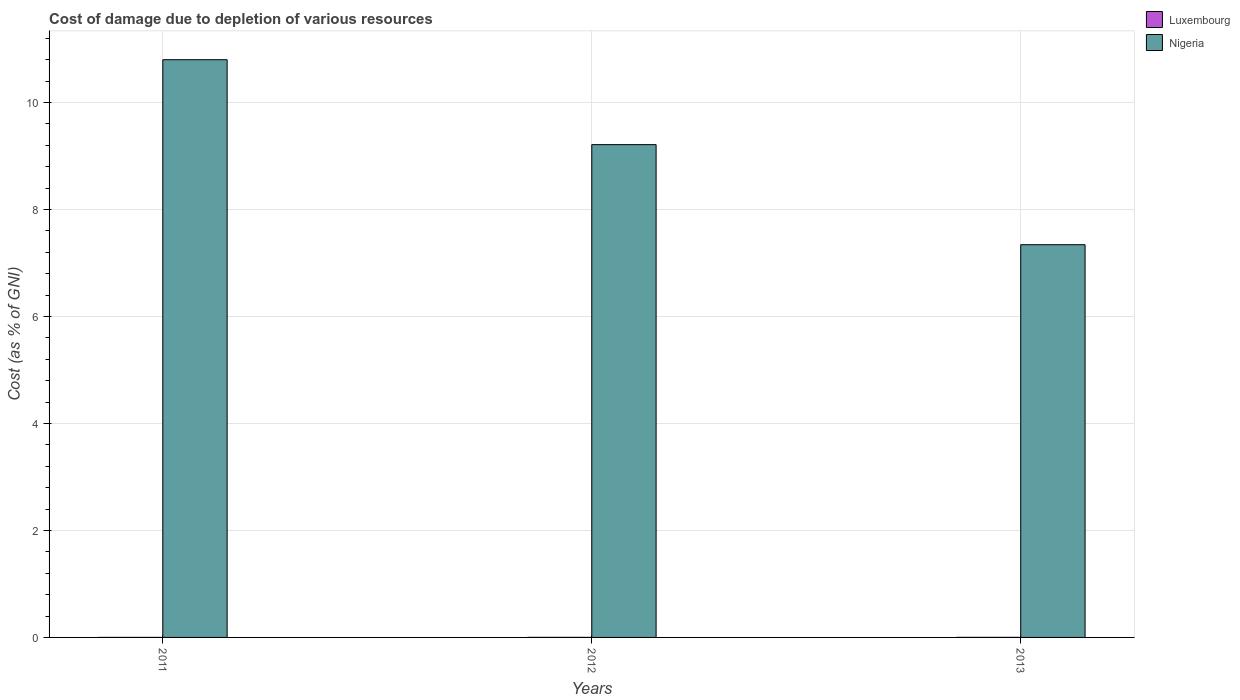How many different coloured bars are there?
Your response must be concise. 2. Are the number of bars per tick equal to the number of legend labels?
Make the answer very short. Yes. Are the number of bars on each tick of the X-axis equal?
Your response must be concise. Yes. How many bars are there on the 1st tick from the right?
Your response must be concise. 2. What is the cost of damage caused due to the depletion of various resources in Nigeria in 2012?
Give a very brief answer. 9.21. Across all years, what is the maximum cost of damage caused due to the depletion of various resources in Luxembourg?
Offer a terse response. 0. Across all years, what is the minimum cost of damage caused due to the depletion of various resources in Nigeria?
Provide a succinct answer. 7.34. In which year was the cost of damage caused due to the depletion of various resources in Nigeria minimum?
Offer a very short reply. 2013. What is the total cost of damage caused due to the depletion of various resources in Luxembourg in the graph?
Give a very brief answer. 0. What is the difference between the cost of damage caused due to the depletion of various resources in Nigeria in 2011 and that in 2012?
Make the answer very short. 1.59. What is the difference between the cost of damage caused due to the depletion of various resources in Nigeria in 2012 and the cost of damage caused due to the depletion of various resources in Luxembourg in 2013?
Offer a terse response. 9.21. What is the average cost of damage caused due to the depletion of various resources in Luxembourg per year?
Offer a very short reply. 0. In the year 2013, what is the difference between the cost of damage caused due to the depletion of various resources in Nigeria and cost of damage caused due to the depletion of various resources in Luxembourg?
Offer a terse response. 7.34. What is the ratio of the cost of damage caused due to the depletion of various resources in Nigeria in 2011 to that in 2013?
Give a very brief answer. 1.47. Is the cost of damage caused due to the depletion of various resources in Luxembourg in 2012 less than that in 2013?
Give a very brief answer. No. What is the difference between the highest and the second highest cost of damage caused due to the depletion of various resources in Nigeria?
Provide a short and direct response. 1.59. What is the difference between the highest and the lowest cost of damage caused due to the depletion of various resources in Nigeria?
Keep it short and to the point. 3.46. Is the sum of the cost of damage caused due to the depletion of various resources in Nigeria in 2011 and 2012 greater than the maximum cost of damage caused due to the depletion of various resources in Luxembourg across all years?
Ensure brevity in your answer.  Yes. What does the 1st bar from the left in 2011 represents?
Provide a succinct answer. Luxembourg. What does the 2nd bar from the right in 2013 represents?
Your answer should be compact. Luxembourg. How many bars are there?
Give a very brief answer. 6. Does the graph contain any zero values?
Make the answer very short. No. Does the graph contain grids?
Your response must be concise. Yes. How are the legend labels stacked?
Your response must be concise. Vertical. What is the title of the graph?
Keep it short and to the point. Cost of damage due to depletion of various resources. What is the label or title of the X-axis?
Your answer should be very brief. Years. What is the label or title of the Y-axis?
Ensure brevity in your answer.  Cost (as % of GNI). What is the Cost (as % of GNI) of Luxembourg in 2011?
Your answer should be compact. 0. What is the Cost (as % of GNI) of Nigeria in 2011?
Ensure brevity in your answer.  10.8. What is the Cost (as % of GNI) of Luxembourg in 2012?
Offer a terse response. 0. What is the Cost (as % of GNI) in Nigeria in 2012?
Offer a very short reply. 9.21. What is the Cost (as % of GNI) of Luxembourg in 2013?
Keep it short and to the point. 0. What is the Cost (as % of GNI) of Nigeria in 2013?
Ensure brevity in your answer.  7.34. Across all years, what is the maximum Cost (as % of GNI) in Luxembourg?
Offer a terse response. 0. Across all years, what is the maximum Cost (as % of GNI) of Nigeria?
Keep it short and to the point. 10.8. Across all years, what is the minimum Cost (as % of GNI) of Luxembourg?
Your answer should be very brief. 0. Across all years, what is the minimum Cost (as % of GNI) in Nigeria?
Give a very brief answer. 7.34. What is the total Cost (as % of GNI) in Luxembourg in the graph?
Keep it short and to the point. 0. What is the total Cost (as % of GNI) of Nigeria in the graph?
Offer a very short reply. 27.35. What is the difference between the Cost (as % of GNI) in Luxembourg in 2011 and that in 2012?
Your answer should be very brief. -0. What is the difference between the Cost (as % of GNI) in Nigeria in 2011 and that in 2012?
Make the answer very short. 1.59. What is the difference between the Cost (as % of GNI) in Luxembourg in 2011 and that in 2013?
Provide a succinct answer. -0. What is the difference between the Cost (as % of GNI) of Nigeria in 2011 and that in 2013?
Ensure brevity in your answer.  3.46. What is the difference between the Cost (as % of GNI) in Nigeria in 2012 and that in 2013?
Give a very brief answer. 1.87. What is the difference between the Cost (as % of GNI) in Luxembourg in 2011 and the Cost (as % of GNI) in Nigeria in 2012?
Your answer should be very brief. -9.21. What is the difference between the Cost (as % of GNI) in Luxembourg in 2011 and the Cost (as % of GNI) in Nigeria in 2013?
Ensure brevity in your answer.  -7.34. What is the difference between the Cost (as % of GNI) of Luxembourg in 2012 and the Cost (as % of GNI) of Nigeria in 2013?
Provide a succinct answer. -7.34. What is the average Cost (as % of GNI) in Luxembourg per year?
Provide a short and direct response. 0. What is the average Cost (as % of GNI) of Nigeria per year?
Give a very brief answer. 9.12. In the year 2011, what is the difference between the Cost (as % of GNI) in Luxembourg and Cost (as % of GNI) in Nigeria?
Provide a succinct answer. -10.8. In the year 2012, what is the difference between the Cost (as % of GNI) of Luxembourg and Cost (as % of GNI) of Nigeria?
Your answer should be compact. -9.21. In the year 2013, what is the difference between the Cost (as % of GNI) in Luxembourg and Cost (as % of GNI) in Nigeria?
Offer a terse response. -7.34. What is the ratio of the Cost (as % of GNI) in Luxembourg in 2011 to that in 2012?
Provide a short and direct response. 0.29. What is the ratio of the Cost (as % of GNI) of Nigeria in 2011 to that in 2012?
Ensure brevity in your answer.  1.17. What is the ratio of the Cost (as % of GNI) in Luxembourg in 2011 to that in 2013?
Provide a succinct answer. 0.3. What is the ratio of the Cost (as % of GNI) of Nigeria in 2011 to that in 2013?
Give a very brief answer. 1.47. What is the ratio of the Cost (as % of GNI) of Luxembourg in 2012 to that in 2013?
Give a very brief answer. 1.01. What is the ratio of the Cost (as % of GNI) in Nigeria in 2012 to that in 2013?
Ensure brevity in your answer.  1.25. What is the difference between the highest and the second highest Cost (as % of GNI) of Luxembourg?
Give a very brief answer. 0. What is the difference between the highest and the second highest Cost (as % of GNI) of Nigeria?
Your response must be concise. 1.59. What is the difference between the highest and the lowest Cost (as % of GNI) of Luxembourg?
Give a very brief answer. 0. What is the difference between the highest and the lowest Cost (as % of GNI) in Nigeria?
Keep it short and to the point. 3.46. 